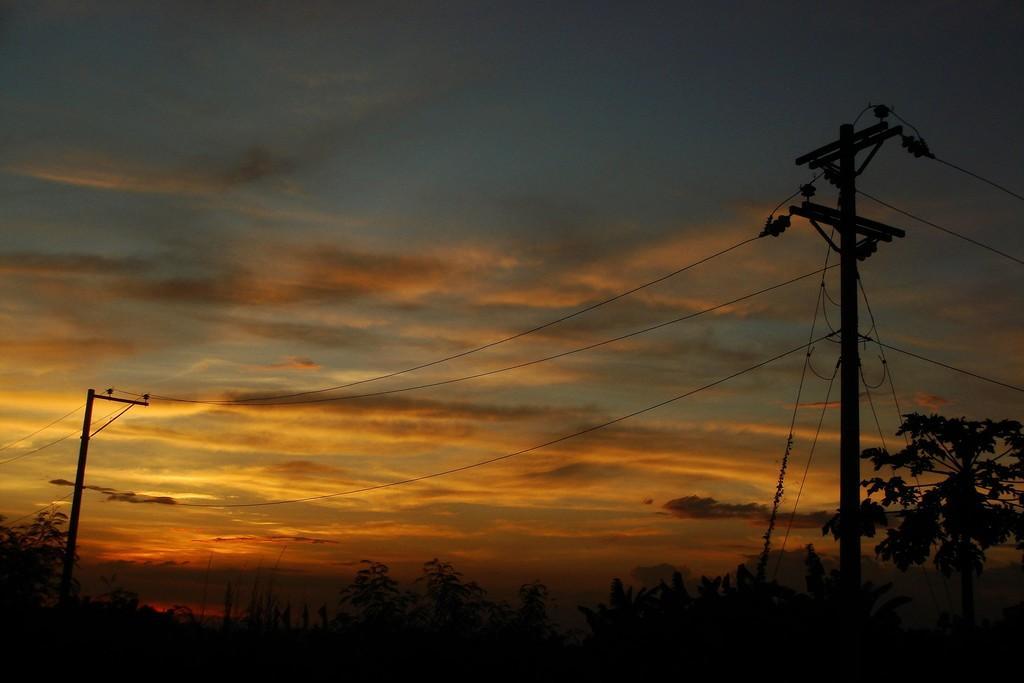Describe this image in one or two sentences. This picture is clicked outside. In the foreground we can see the trees, poles and cables. In the background we can see the sky with the clouds. 